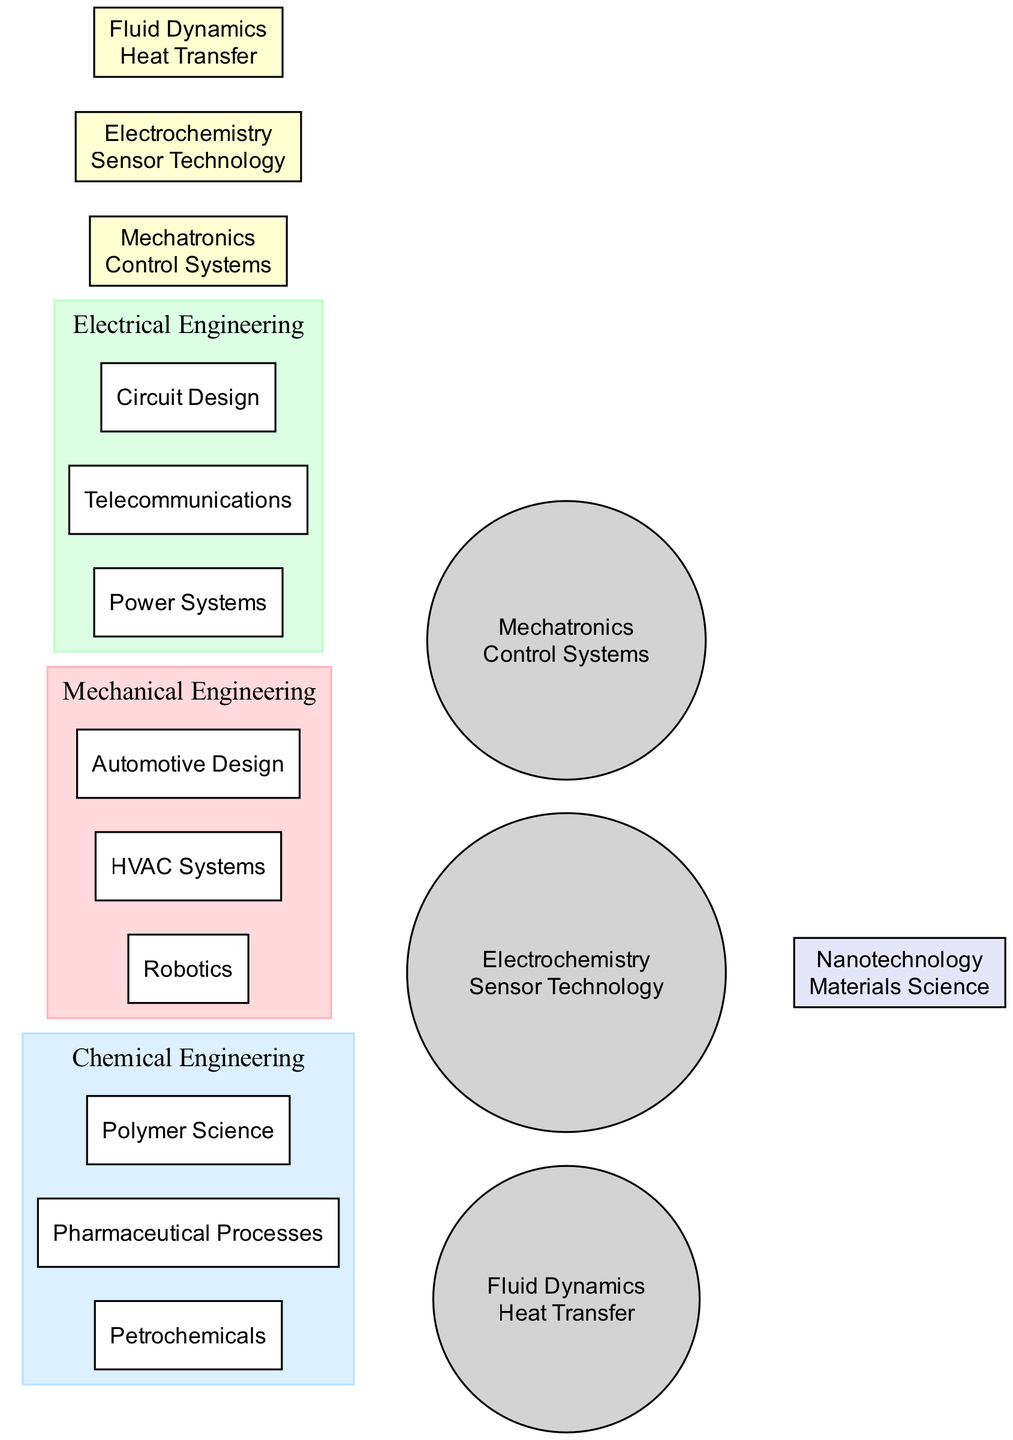What unique element is associated with Electrical Engineering? The unique elements associated with Electrical Engineering are listed within the circle labeled "Electrical Engineering." One of these unique elements is "Power Systems," which is explicitly mentioned.
Answer: Power Systems How many unique elements does Mechanical Engineering have? The diagram displays a listing of unique elements within the "Mechanical Engineering" circle. Counting them reveals there are three unique elements: Robotics, HVAC Systems, and Automotive Design.
Answer: 3 What are the overlapping elements between Mechanical and Chemical Engineering? Within the overlaps section, the elements that are shared between Mechanical and Chemical Engineering are clearly specified. They are "Fluid Dynamics" and "Heat Transfer."
Answer: Fluid Dynamics, Heat Transfer Which engineering disciplines intersect through Nanotechnology? The overlap labeled for three disciplines shows that Nanotechnology is a common element between Mechanical, Electrical, and Chemical Engineering. This indicates that all three disciplines share this area.
Answer: Mechanical, Electrical, Chemical What is the relationship between Sensor Technology and Electrical Engineering? The relationship is defined in the overlaps section of the diagram, where Sensor Technology is mentioned as an overlapping element between Electrical and Chemical Engineering, indicating a connection but not exclusively with Electrical Engineering alone.
Answer: Overlapping with Chemical Engineering How many elements are unique to Chemical Engineering? The diagram lists three unique elements within the "Chemical Engineering" circle, specifically Petrochemicals, Pharmaceutical Processes, and Polymer Science. Counting these gives the total number of unique elements.
Answer: 3 What are the distinct fields represented in this Venn diagram? The diagram includes three distinct fields of engineering: "Mechanical Engineering," "Electrical Engineering," and "Chemical Engineering." Each of these is represented by its own circle.
Answer: Mechanical, Electrical, Chemical How many overlaps are there in total depicted in the diagram? The diagram shows multiple overlap areas. Counting the listed overlaps reveals there are four distinct overlap areas: between Mechanical and Electrical, Electrical and Chemical, Mechanical and Chemical, and the central area involving all three disciplines.
Answer: 4 What elements are shared between Electrical and Chemical Engineering? The overlap section highlights that Electrochemistry and Sensor Technology are specifically mentioned as common elements shared between the Electrical and Chemical Engineering disciplines.
Answer: Electrochemistry, Sensor Technology 